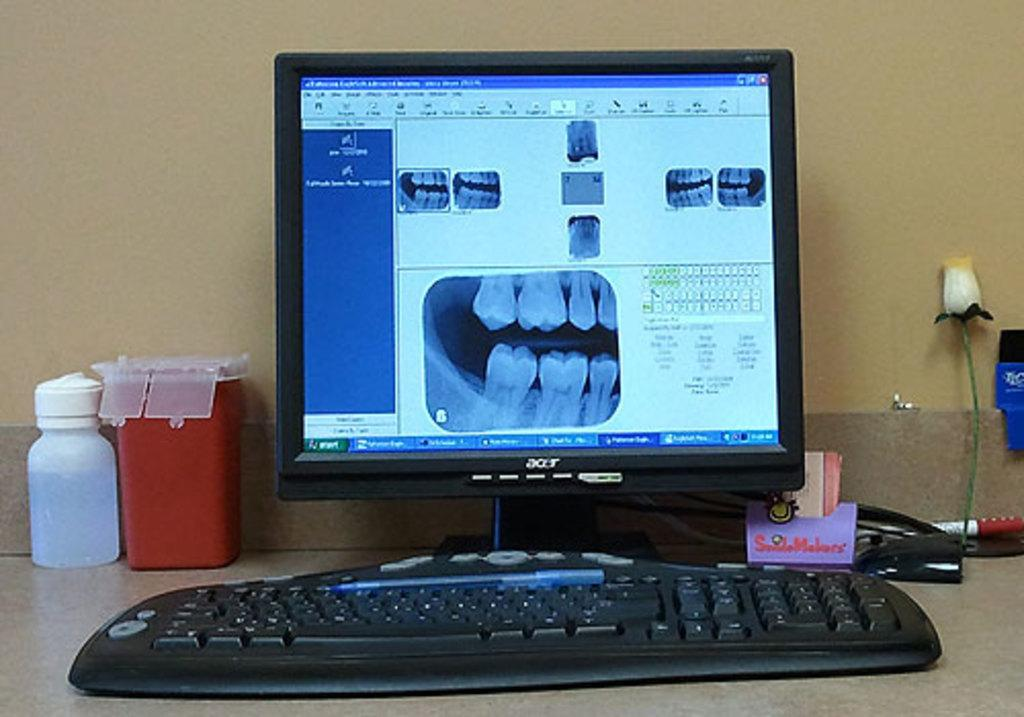What electronic device is visible on a surface in the image? There is a monitor on a surface in the image. What is used for typing on a surface in the image? There is a keyboard on a surface in the image. What type of container is present on a surface in the image? There is a red box on a surface in the image. What decorative item can be seen on a surface in the image? There is a plastic flower on a surface in the image. What is the background of the image? There is a wall at the back in the image. What is the name of the bee buzzing around the monitor in the image? There is no bee present in the image; it only features a monitor, keyboard, bottle, red box, plastic flower, and other objects on a surface, as well as a wall at the back. 